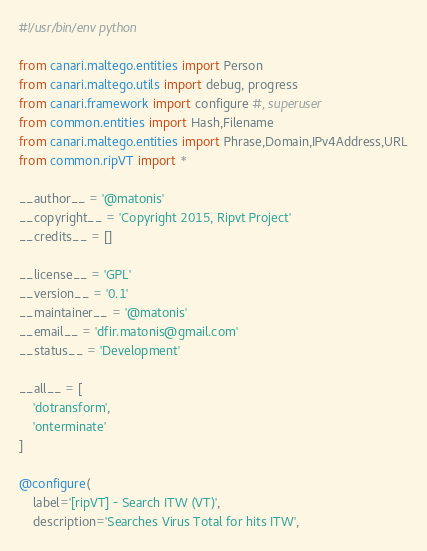<code> <loc_0><loc_0><loc_500><loc_500><_Python_>#!/usr/bin/env python

from canari.maltego.entities import Person
from canari.maltego.utils import debug, progress
from canari.framework import configure #, superuser
from common.entities import Hash,Filename
from canari.maltego.entities import Phrase,Domain,IPv4Address,URL
from common.ripVT import *

__author__ = '@matonis'
__copyright__ = 'Copyright 2015, Ripvt Project'
__credits__ = []

__license__ = 'GPL'
__version__ = '0.1'
__maintainer__ = '@matonis'
__email__ = 'dfir.matonis@gmail.com'
__status__ = 'Development'

__all__ = [
    'dotransform',
    'onterminate'
]

@configure(
    label='[ripVT] - Search ITW (VT)',
    description='Searches Virus Total for hits ITW',</code> 